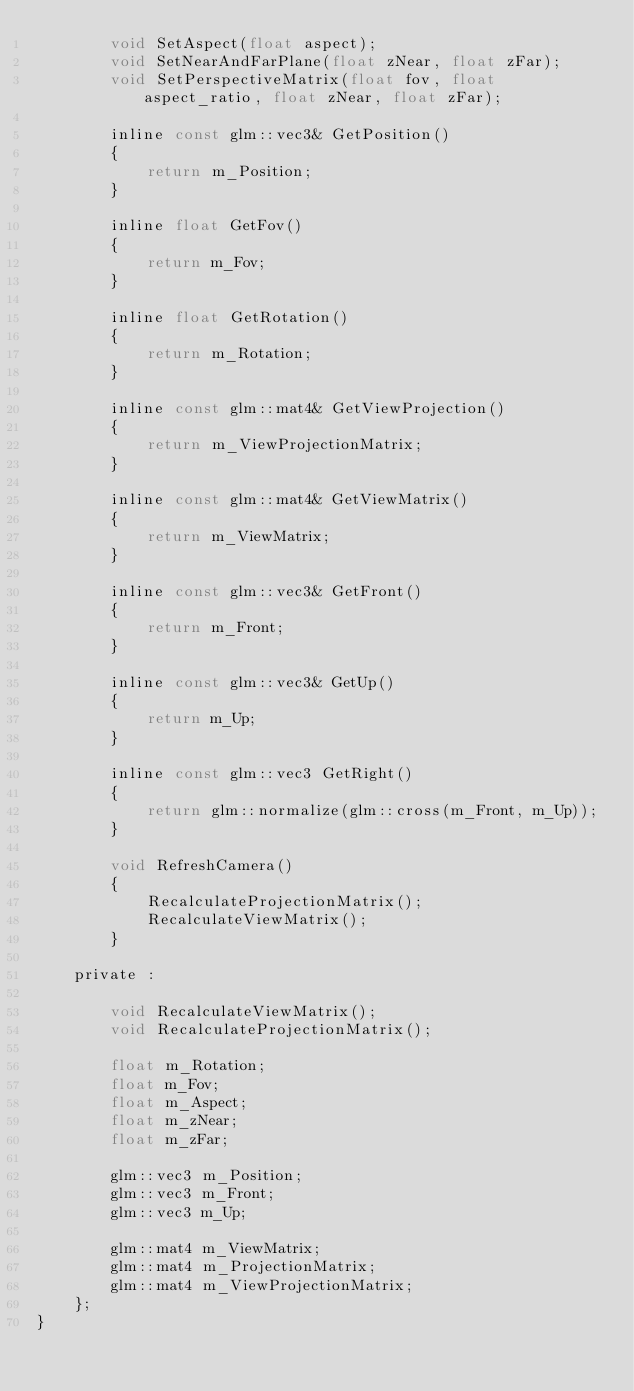Convert code to text. <code><loc_0><loc_0><loc_500><loc_500><_C_>		void SetAspect(float aspect);
		void SetNearAndFarPlane(float zNear, float zFar);
		void SetPerspectiveMatrix(float fov, float aspect_ratio, float zNear, float zFar);

		inline const glm::vec3& GetPosition()
		{
			return m_Position;
		}

		inline float GetFov()
		{
			return m_Fov;
		}

		inline float GetRotation()
		{
			return m_Rotation;
		}

		inline const glm::mat4& GetViewProjection()
		{
			return m_ViewProjectionMatrix;
		}

		inline const glm::mat4& GetViewMatrix()
		{
			return m_ViewMatrix;
		}

		inline const glm::vec3& GetFront()
		{
			return m_Front;
		}

		inline const glm::vec3& GetUp()
		{
			return m_Up;
		}

		inline const glm::vec3 GetRight()
		{
			return glm::normalize(glm::cross(m_Front, m_Up));
		}

		void RefreshCamera()
		{
			RecalculateProjectionMatrix();
			RecalculateViewMatrix();
		}

	private : 

		void RecalculateViewMatrix();
		void RecalculateProjectionMatrix();

		float m_Rotation;
		float m_Fov;
		float m_Aspect;
		float m_zNear;
		float m_zFar;

		glm::vec3 m_Position;
		glm::vec3 m_Front;
		glm::vec3 m_Up;

		glm::mat4 m_ViewMatrix;
		glm::mat4 m_ProjectionMatrix;
		glm::mat4 m_ViewProjectionMatrix;
	};
}</code> 